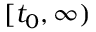Convert formula to latex. <formula><loc_0><loc_0><loc_500><loc_500>[ t _ { 0 } , \infty )</formula> 